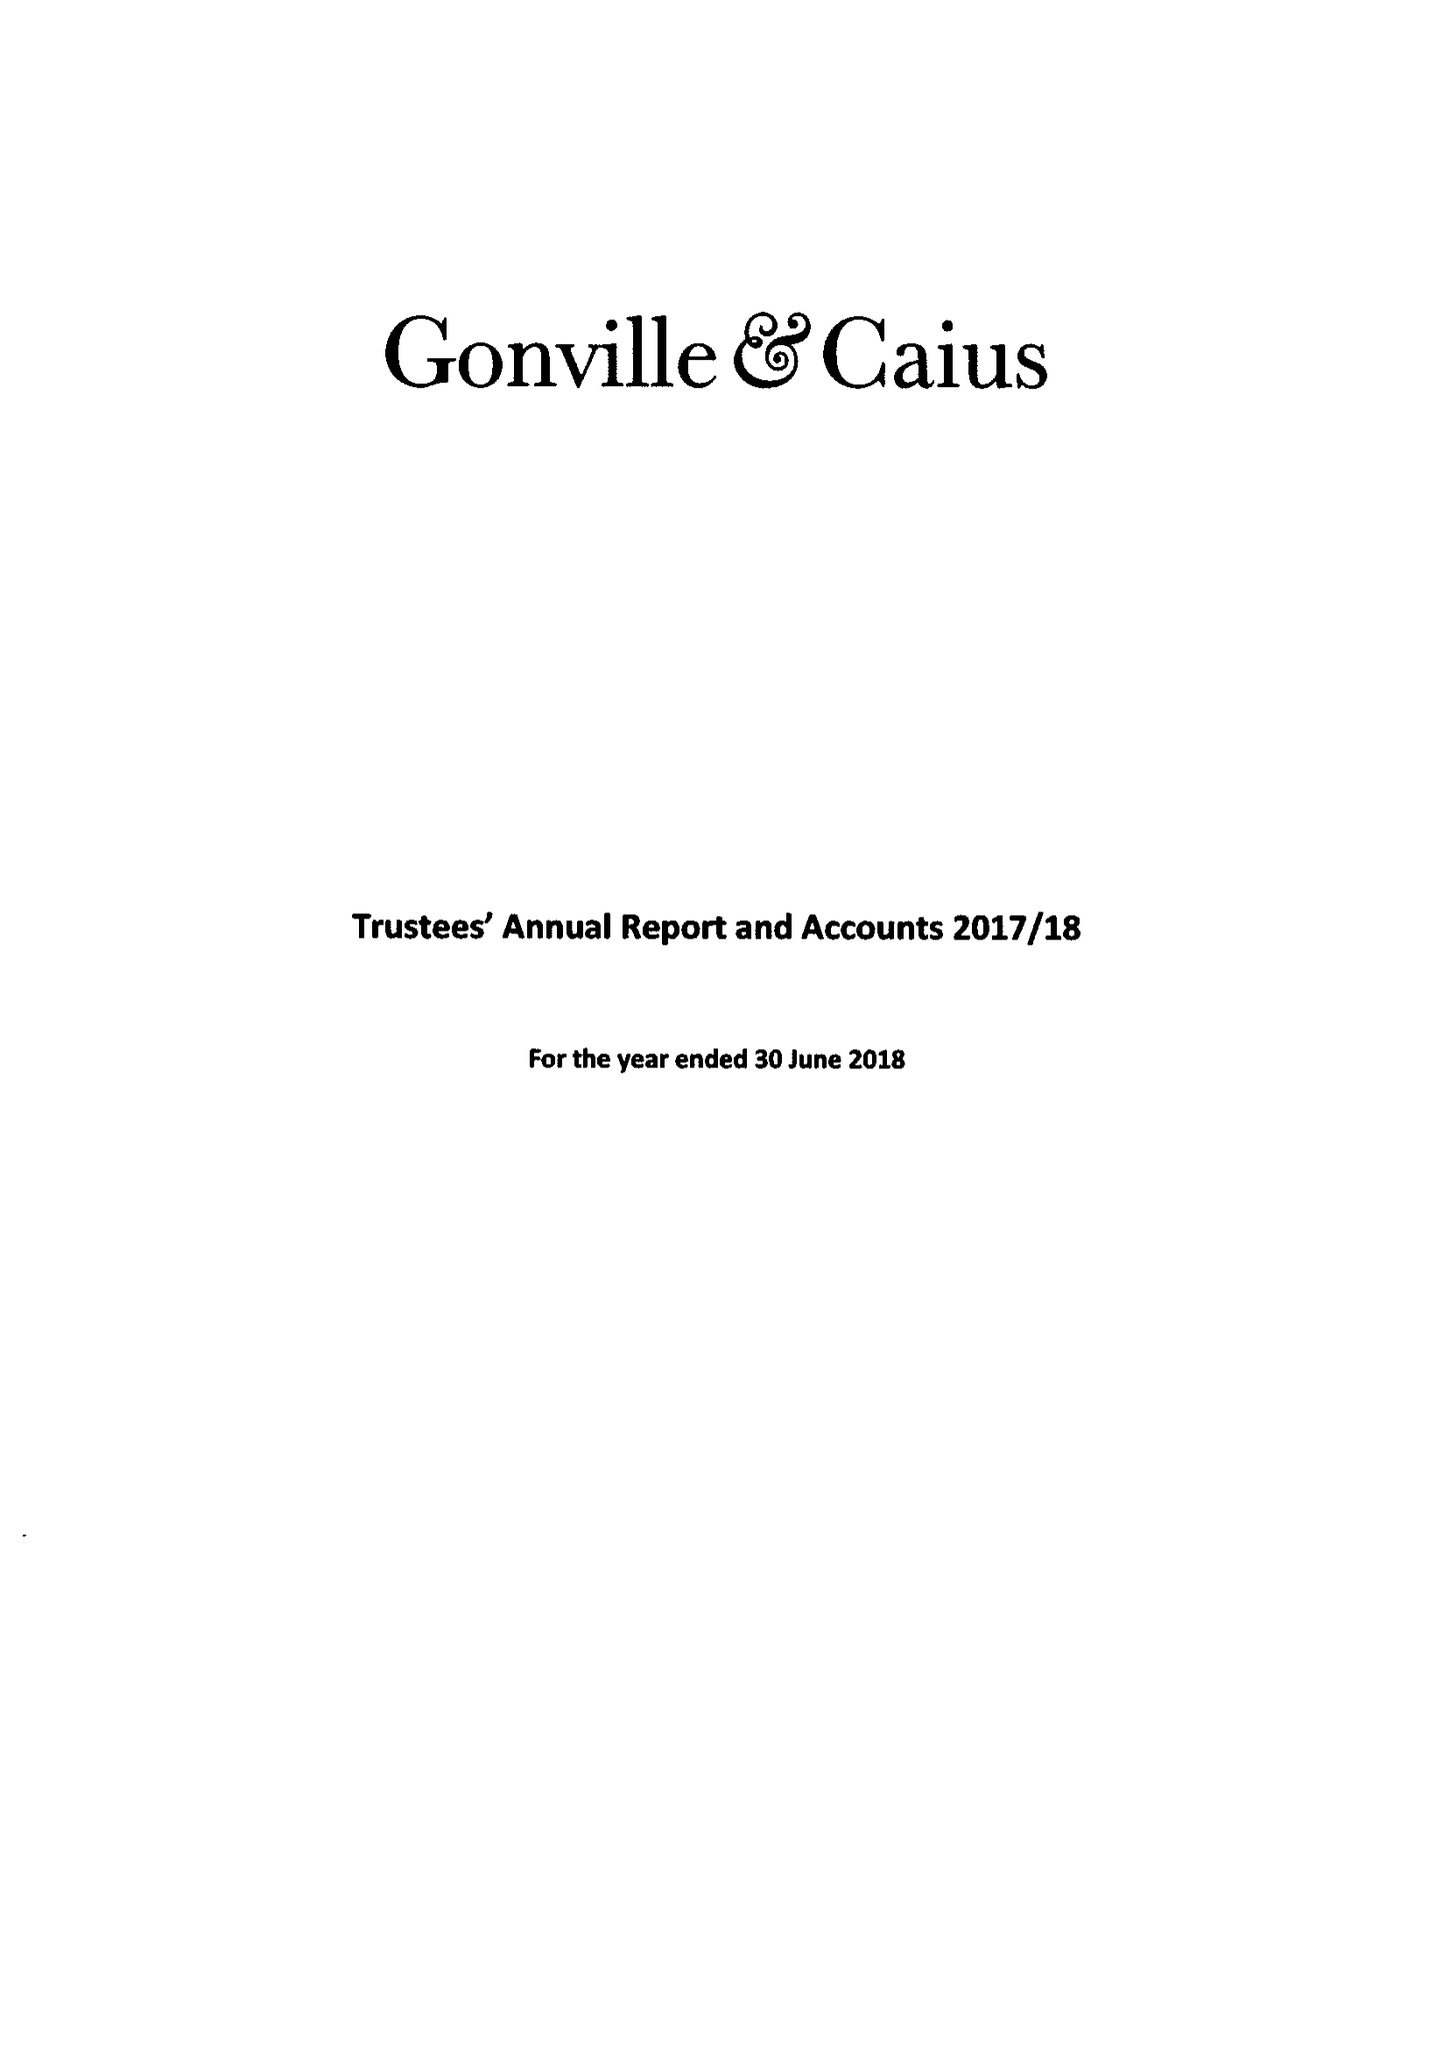What is the value for the address__postcode?
Answer the question using a single word or phrase. CB2 1TA 